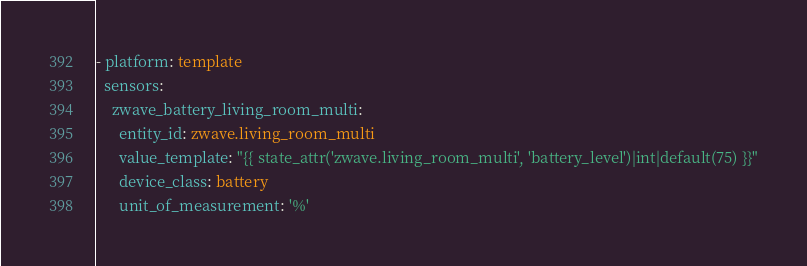<code> <loc_0><loc_0><loc_500><loc_500><_YAML_>- platform: template
  sensors:
    zwave_battery_living_room_multi:
      entity_id: zwave.living_room_multi
      value_template: "{{ state_attr('zwave.living_room_multi', 'battery_level')|int|default(75) }}"
      device_class: battery
      unit_of_measurement: '%'
</code> 